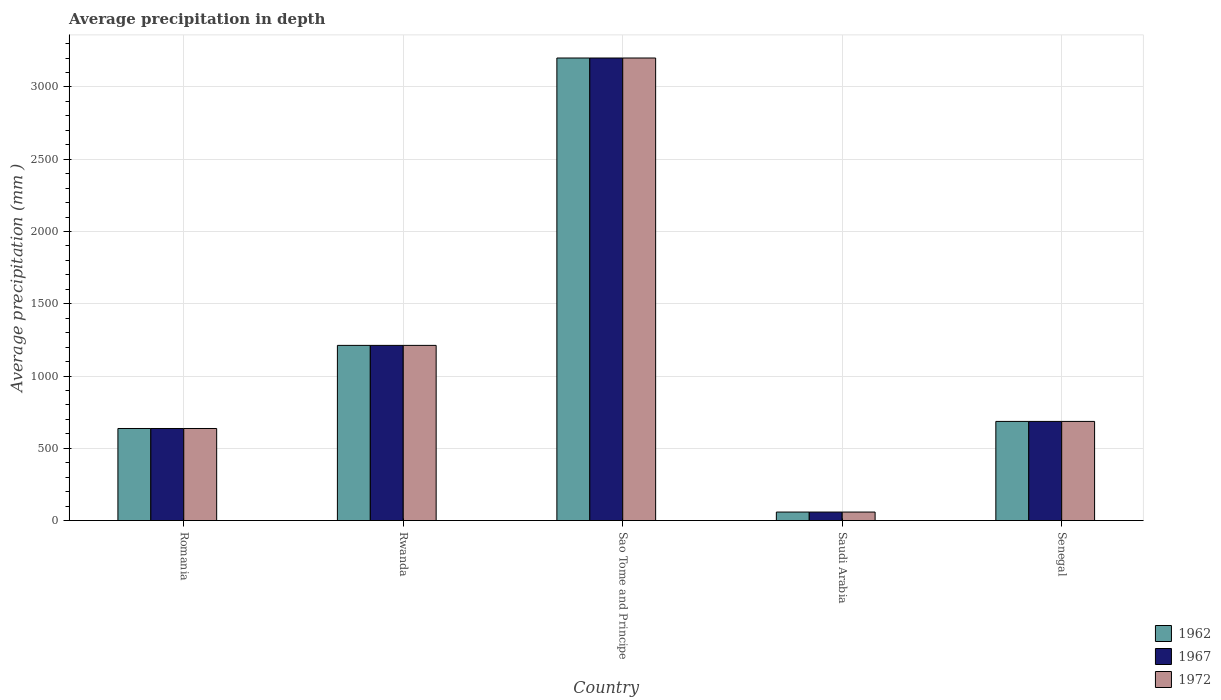Are the number of bars per tick equal to the number of legend labels?
Give a very brief answer. Yes. Are the number of bars on each tick of the X-axis equal?
Ensure brevity in your answer.  Yes. How many bars are there on the 2nd tick from the left?
Your answer should be compact. 3. What is the label of the 1st group of bars from the left?
Ensure brevity in your answer.  Romania. In how many cases, is the number of bars for a given country not equal to the number of legend labels?
Your answer should be very brief. 0. What is the average precipitation in 1962 in Senegal?
Your answer should be compact. 686. Across all countries, what is the maximum average precipitation in 1967?
Your answer should be compact. 3200. In which country was the average precipitation in 1962 maximum?
Your answer should be compact. Sao Tome and Principe. In which country was the average precipitation in 1972 minimum?
Ensure brevity in your answer.  Saudi Arabia. What is the total average precipitation in 1967 in the graph?
Offer a terse response. 5794. What is the difference between the average precipitation in 1972 in Romania and that in Rwanda?
Keep it short and to the point. -575. What is the difference between the average precipitation in 1972 in Sao Tome and Principe and the average precipitation in 1967 in Senegal?
Keep it short and to the point. 2514. What is the average average precipitation in 1962 per country?
Give a very brief answer. 1158.8. What is the ratio of the average precipitation in 1967 in Sao Tome and Principe to that in Saudi Arabia?
Give a very brief answer. 54.24. Is the average precipitation in 1962 in Rwanda less than that in Senegal?
Your response must be concise. No. What is the difference between the highest and the second highest average precipitation in 1962?
Your answer should be compact. 1988. What is the difference between the highest and the lowest average precipitation in 1972?
Your answer should be compact. 3141. What does the 2nd bar from the left in Senegal represents?
Your answer should be very brief. 1967. What does the 2nd bar from the right in Rwanda represents?
Provide a short and direct response. 1967. Are all the bars in the graph horizontal?
Provide a short and direct response. No. What is the difference between two consecutive major ticks on the Y-axis?
Give a very brief answer. 500. Does the graph contain grids?
Your answer should be very brief. Yes. Where does the legend appear in the graph?
Ensure brevity in your answer.  Bottom right. How many legend labels are there?
Your answer should be compact. 3. How are the legend labels stacked?
Offer a very short reply. Vertical. What is the title of the graph?
Provide a succinct answer. Average precipitation in depth. Does "1964" appear as one of the legend labels in the graph?
Give a very brief answer. No. What is the label or title of the Y-axis?
Make the answer very short. Average precipitation (mm ). What is the Average precipitation (mm ) in 1962 in Romania?
Keep it short and to the point. 637. What is the Average precipitation (mm ) of 1967 in Romania?
Your answer should be compact. 637. What is the Average precipitation (mm ) of 1972 in Romania?
Give a very brief answer. 637. What is the Average precipitation (mm ) of 1962 in Rwanda?
Your answer should be very brief. 1212. What is the Average precipitation (mm ) of 1967 in Rwanda?
Your answer should be very brief. 1212. What is the Average precipitation (mm ) in 1972 in Rwanda?
Your response must be concise. 1212. What is the Average precipitation (mm ) in 1962 in Sao Tome and Principe?
Provide a short and direct response. 3200. What is the Average precipitation (mm ) in 1967 in Sao Tome and Principe?
Keep it short and to the point. 3200. What is the Average precipitation (mm ) of 1972 in Sao Tome and Principe?
Offer a very short reply. 3200. What is the Average precipitation (mm ) in 1962 in Saudi Arabia?
Your response must be concise. 59. What is the Average precipitation (mm ) in 1967 in Saudi Arabia?
Ensure brevity in your answer.  59. What is the Average precipitation (mm ) of 1972 in Saudi Arabia?
Keep it short and to the point. 59. What is the Average precipitation (mm ) in 1962 in Senegal?
Keep it short and to the point. 686. What is the Average precipitation (mm ) in 1967 in Senegal?
Keep it short and to the point. 686. What is the Average precipitation (mm ) of 1972 in Senegal?
Provide a short and direct response. 686. Across all countries, what is the maximum Average precipitation (mm ) in 1962?
Provide a succinct answer. 3200. Across all countries, what is the maximum Average precipitation (mm ) in 1967?
Make the answer very short. 3200. Across all countries, what is the maximum Average precipitation (mm ) in 1972?
Your answer should be compact. 3200. Across all countries, what is the minimum Average precipitation (mm ) in 1962?
Provide a short and direct response. 59. What is the total Average precipitation (mm ) in 1962 in the graph?
Your answer should be very brief. 5794. What is the total Average precipitation (mm ) in 1967 in the graph?
Your answer should be very brief. 5794. What is the total Average precipitation (mm ) in 1972 in the graph?
Your response must be concise. 5794. What is the difference between the Average precipitation (mm ) in 1962 in Romania and that in Rwanda?
Give a very brief answer. -575. What is the difference between the Average precipitation (mm ) of 1967 in Romania and that in Rwanda?
Your answer should be compact. -575. What is the difference between the Average precipitation (mm ) of 1972 in Romania and that in Rwanda?
Your response must be concise. -575. What is the difference between the Average precipitation (mm ) of 1962 in Romania and that in Sao Tome and Principe?
Keep it short and to the point. -2563. What is the difference between the Average precipitation (mm ) of 1967 in Romania and that in Sao Tome and Principe?
Offer a very short reply. -2563. What is the difference between the Average precipitation (mm ) in 1972 in Romania and that in Sao Tome and Principe?
Provide a short and direct response. -2563. What is the difference between the Average precipitation (mm ) of 1962 in Romania and that in Saudi Arabia?
Offer a terse response. 578. What is the difference between the Average precipitation (mm ) in 1967 in Romania and that in Saudi Arabia?
Offer a very short reply. 578. What is the difference between the Average precipitation (mm ) in 1972 in Romania and that in Saudi Arabia?
Your answer should be compact. 578. What is the difference between the Average precipitation (mm ) of 1962 in Romania and that in Senegal?
Ensure brevity in your answer.  -49. What is the difference between the Average precipitation (mm ) of 1967 in Romania and that in Senegal?
Offer a terse response. -49. What is the difference between the Average precipitation (mm ) in 1972 in Romania and that in Senegal?
Make the answer very short. -49. What is the difference between the Average precipitation (mm ) of 1962 in Rwanda and that in Sao Tome and Principe?
Offer a very short reply. -1988. What is the difference between the Average precipitation (mm ) of 1967 in Rwanda and that in Sao Tome and Principe?
Give a very brief answer. -1988. What is the difference between the Average precipitation (mm ) of 1972 in Rwanda and that in Sao Tome and Principe?
Give a very brief answer. -1988. What is the difference between the Average precipitation (mm ) of 1962 in Rwanda and that in Saudi Arabia?
Offer a very short reply. 1153. What is the difference between the Average precipitation (mm ) in 1967 in Rwanda and that in Saudi Arabia?
Your answer should be very brief. 1153. What is the difference between the Average precipitation (mm ) of 1972 in Rwanda and that in Saudi Arabia?
Provide a succinct answer. 1153. What is the difference between the Average precipitation (mm ) in 1962 in Rwanda and that in Senegal?
Keep it short and to the point. 526. What is the difference between the Average precipitation (mm ) in 1967 in Rwanda and that in Senegal?
Your answer should be compact. 526. What is the difference between the Average precipitation (mm ) of 1972 in Rwanda and that in Senegal?
Your answer should be very brief. 526. What is the difference between the Average precipitation (mm ) in 1962 in Sao Tome and Principe and that in Saudi Arabia?
Ensure brevity in your answer.  3141. What is the difference between the Average precipitation (mm ) of 1967 in Sao Tome and Principe and that in Saudi Arabia?
Give a very brief answer. 3141. What is the difference between the Average precipitation (mm ) in 1972 in Sao Tome and Principe and that in Saudi Arabia?
Offer a very short reply. 3141. What is the difference between the Average precipitation (mm ) of 1962 in Sao Tome and Principe and that in Senegal?
Keep it short and to the point. 2514. What is the difference between the Average precipitation (mm ) in 1967 in Sao Tome and Principe and that in Senegal?
Ensure brevity in your answer.  2514. What is the difference between the Average precipitation (mm ) in 1972 in Sao Tome and Principe and that in Senegal?
Your response must be concise. 2514. What is the difference between the Average precipitation (mm ) of 1962 in Saudi Arabia and that in Senegal?
Your response must be concise. -627. What is the difference between the Average precipitation (mm ) in 1967 in Saudi Arabia and that in Senegal?
Your answer should be compact. -627. What is the difference between the Average precipitation (mm ) of 1972 in Saudi Arabia and that in Senegal?
Give a very brief answer. -627. What is the difference between the Average precipitation (mm ) in 1962 in Romania and the Average precipitation (mm ) in 1967 in Rwanda?
Give a very brief answer. -575. What is the difference between the Average precipitation (mm ) of 1962 in Romania and the Average precipitation (mm ) of 1972 in Rwanda?
Provide a short and direct response. -575. What is the difference between the Average precipitation (mm ) in 1967 in Romania and the Average precipitation (mm ) in 1972 in Rwanda?
Keep it short and to the point. -575. What is the difference between the Average precipitation (mm ) in 1962 in Romania and the Average precipitation (mm ) in 1967 in Sao Tome and Principe?
Offer a very short reply. -2563. What is the difference between the Average precipitation (mm ) of 1962 in Romania and the Average precipitation (mm ) of 1972 in Sao Tome and Principe?
Provide a succinct answer. -2563. What is the difference between the Average precipitation (mm ) in 1967 in Romania and the Average precipitation (mm ) in 1972 in Sao Tome and Principe?
Your answer should be compact. -2563. What is the difference between the Average precipitation (mm ) in 1962 in Romania and the Average precipitation (mm ) in 1967 in Saudi Arabia?
Your answer should be very brief. 578. What is the difference between the Average precipitation (mm ) in 1962 in Romania and the Average precipitation (mm ) in 1972 in Saudi Arabia?
Your response must be concise. 578. What is the difference between the Average precipitation (mm ) of 1967 in Romania and the Average precipitation (mm ) of 1972 in Saudi Arabia?
Give a very brief answer. 578. What is the difference between the Average precipitation (mm ) of 1962 in Romania and the Average precipitation (mm ) of 1967 in Senegal?
Provide a succinct answer. -49. What is the difference between the Average precipitation (mm ) in 1962 in Romania and the Average precipitation (mm ) in 1972 in Senegal?
Make the answer very short. -49. What is the difference between the Average precipitation (mm ) in 1967 in Romania and the Average precipitation (mm ) in 1972 in Senegal?
Provide a succinct answer. -49. What is the difference between the Average precipitation (mm ) in 1962 in Rwanda and the Average precipitation (mm ) in 1967 in Sao Tome and Principe?
Your response must be concise. -1988. What is the difference between the Average precipitation (mm ) in 1962 in Rwanda and the Average precipitation (mm ) in 1972 in Sao Tome and Principe?
Provide a short and direct response. -1988. What is the difference between the Average precipitation (mm ) of 1967 in Rwanda and the Average precipitation (mm ) of 1972 in Sao Tome and Principe?
Your answer should be compact. -1988. What is the difference between the Average precipitation (mm ) of 1962 in Rwanda and the Average precipitation (mm ) of 1967 in Saudi Arabia?
Give a very brief answer. 1153. What is the difference between the Average precipitation (mm ) of 1962 in Rwanda and the Average precipitation (mm ) of 1972 in Saudi Arabia?
Provide a short and direct response. 1153. What is the difference between the Average precipitation (mm ) in 1967 in Rwanda and the Average precipitation (mm ) in 1972 in Saudi Arabia?
Your answer should be very brief. 1153. What is the difference between the Average precipitation (mm ) of 1962 in Rwanda and the Average precipitation (mm ) of 1967 in Senegal?
Your answer should be compact. 526. What is the difference between the Average precipitation (mm ) of 1962 in Rwanda and the Average precipitation (mm ) of 1972 in Senegal?
Your answer should be very brief. 526. What is the difference between the Average precipitation (mm ) in 1967 in Rwanda and the Average precipitation (mm ) in 1972 in Senegal?
Offer a terse response. 526. What is the difference between the Average precipitation (mm ) of 1962 in Sao Tome and Principe and the Average precipitation (mm ) of 1967 in Saudi Arabia?
Your answer should be very brief. 3141. What is the difference between the Average precipitation (mm ) of 1962 in Sao Tome and Principe and the Average precipitation (mm ) of 1972 in Saudi Arabia?
Make the answer very short. 3141. What is the difference between the Average precipitation (mm ) in 1967 in Sao Tome and Principe and the Average precipitation (mm ) in 1972 in Saudi Arabia?
Provide a succinct answer. 3141. What is the difference between the Average precipitation (mm ) in 1962 in Sao Tome and Principe and the Average precipitation (mm ) in 1967 in Senegal?
Provide a short and direct response. 2514. What is the difference between the Average precipitation (mm ) in 1962 in Sao Tome and Principe and the Average precipitation (mm ) in 1972 in Senegal?
Provide a short and direct response. 2514. What is the difference between the Average precipitation (mm ) of 1967 in Sao Tome and Principe and the Average precipitation (mm ) of 1972 in Senegal?
Keep it short and to the point. 2514. What is the difference between the Average precipitation (mm ) of 1962 in Saudi Arabia and the Average precipitation (mm ) of 1967 in Senegal?
Your response must be concise. -627. What is the difference between the Average precipitation (mm ) of 1962 in Saudi Arabia and the Average precipitation (mm ) of 1972 in Senegal?
Provide a succinct answer. -627. What is the difference between the Average precipitation (mm ) in 1967 in Saudi Arabia and the Average precipitation (mm ) in 1972 in Senegal?
Provide a short and direct response. -627. What is the average Average precipitation (mm ) of 1962 per country?
Offer a very short reply. 1158.8. What is the average Average precipitation (mm ) of 1967 per country?
Your response must be concise. 1158.8. What is the average Average precipitation (mm ) in 1972 per country?
Ensure brevity in your answer.  1158.8. What is the difference between the Average precipitation (mm ) of 1967 and Average precipitation (mm ) of 1972 in Romania?
Your response must be concise. 0. What is the difference between the Average precipitation (mm ) of 1962 and Average precipitation (mm ) of 1972 in Rwanda?
Keep it short and to the point. 0. What is the difference between the Average precipitation (mm ) in 1967 and Average precipitation (mm ) in 1972 in Rwanda?
Offer a terse response. 0. What is the difference between the Average precipitation (mm ) of 1967 and Average precipitation (mm ) of 1972 in Sao Tome and Principe?
Offer a terse response. 0. What is the difference between the Average precipitation (mm ) of 1962 and Average precipitation (mm ) of 1967 in Saudi Arabia?
Give a very brief answer. 0. What is the difference between the Average precipitation (mm ) of 1962 and Average precipitation (mm ) of 1972 in Saudi Arabia?
Offer a terse response. 0. What is the difference between the Average precipitation (mm ) of 1967 and Average precipitation (mm ) of 1972 in Saudi Arabia?
Offer a very short reply. 0. What is the difference between the Average precipitation (mm ) in 1962 and Average precipitation (mm ) in 1967 in Senegal?
Your response must be concise. 0. What is the difference between the Average precipitation (mm ) of 1962 and Average precipitation (mm ) of 1972 in Senegal?
Keep it short and to the point. 0. What is the ratio of the Average precipitation (mm ) in 1962 in Romania to that in Rwanda?
Keep it short and to the point. 0.53. What is the ratio of the Average precipitation (mm ) in 1967 in Romania to that in Rwanda?
Your answer should be compact. 0.53. What is the ratio of the Average precipitation (mm ) of 1972 in Romania to that in Rwanda?
Keep it short and to the point. 0.53. What is the ratio of the Average precipitation (mm ) of 1962 in Romania to that in Sao Tome and Principe?
Your answer should be compact. 0.2. What is the ratio of the Average precipitation (mm ) of 1967 in Romania to that in Sao Tome and Principe?
Ensure brevity in your answer.  0.2. What is the ratio of the Average precipitation (mm ) in 1972 in Romania to that in Sao Tome and Principe?
Your answer should be very brief. 0.2. What is the ratio of the Average precipitation (mm ) of 1962 in Romania to that in Saudi Arabia?
Give a very brief answer. 10.8. What is the ratio of the Average precipitation (mm ) in 1967 in Romania to that in Saudi Arabia?
Keep it short and to the point. 10.8. What is the ratio of the Average precipitation (mm ) of 1972 in Romania to that in Saudi Arabia?
Give a very brief answer. 10.8. What is the ratio of the Average precipitation (mm ) of 1962 in Romania to that in Senegal?
Keep it short and to the point. 0.93. What is the ratio of the Average precipitation (mm ) in 1967 in Romania to that in Senegal?
Make the answer very short. 0.93. What is the ratio of the Average precipitation (mm ) in 1962 in Rwanda to that in Sao Tome and Principe?
Your response must be concise. 0.38. What is the ratio of the Average precipitation (mm ) in 1967 in Rwanda to that in Sao Tome and Principe?
Your response must be concise. 0.38. What is the ratio of the Average precipitation (mm ) of 1972 in Rwanda to that in Sao Tome and Principe?
Your answer should be very brief. 0.38. What is the ratio of the Average precipitation (mm ) of 1962 in Rwanda to that in Saudi Arabia?
Offer a very short reply. 20.54. What is the ratio of the Average precipitation (mm ) of 1967 in Rwanda to that in Saudi Arabia?
Ensure brevity in your answer.  20.54. What is the ratio of the Average precipitation (mm ) of 1972 in Rwanda to that in Saudi Arabia?
Make the answer very short. 20.54. What is the ratio of the Average precipitation (mm ) in 1962 in Rwanda to that in Senegal?
Keep it short and to the point. 1.77. What is the ratio of the Average precipitation (mm ) in 1967 in Rwanda to that in Senegal?
Keep it short and to the point. 1.77. What is the ratio of the Average precipitation (mm ) of 1972 in Rwanda to that in Senegal?
Ensure brevity in your answer.  1.77. What is the ratio of the Average precipitation (mm ) in 1962 in Sao Tome and Principe to that in Saudi Arabia?
Your response must be concise. 54.24. What is the ratio of the Average precipitation (mm ) of 1967 in Sao Tome and Principe to that in Saudi Arabia?
Your answer should be very brief. 54.24. What is the ratio of the Average precipitation (mm ) of 1972 in Sao Tome and Principe to that in Saudi Arabia?
Provide a succinct answer. 54.24. What is the ratio of the Average precipitation (mm ) in 1962 in Sao Tome and Principe to that in Senegal?
Make the answer very short. 4.66. What is the ratio of the Average precipitation (mm ) of 1967 in Sao Tome and Principe to that in Senegal?
Give a very brief answer. 4.66. What is the ratio of the Average precipitation (mm ) in 1972 in Sao Tome and Principe to that in Senegal?
Give a very brief answer. 4.66. What is the ratio of the Average precipitation (mm ) in 1962 in Saudi Arabia to that in Senegal?
Your response must be concise. 0.09. What is the ratio of the Average precipitation (mm ) in 1967 in Saudi Arabia to that in Senegal?
Your answer should be very brief. 0.09. What is the ratio of the Average precipitation (mm ) of 1972 in Saudi Arabia to that in Senegal?
Ensure brevity in your answer.  0.09. What is the difference between the highest and the second highest Average precipitation (mm ) of 1962?
Offer a terse response. 1988. What is the difference between the highest and the second highest Average precipitation (mm ) in 1967?
Provide a succinct answer. 1988. What is the difference between the highest and the second highest Average precipitation (mm ) in 1972?
Ensure brevity in your answer.  1988. What is the difference between the highest and the lowest Average precipitation (mm ) in 1962?
Keep it short and to the point. 3141. What is the difference between the highest and the lowest Average precipitation (mm ) in 1967?
Offer a terse response. 3141. What is the difference between the highest and the lowest Average precipitation (mm ) in 1972?
Keep it short and to the point. 3141. 